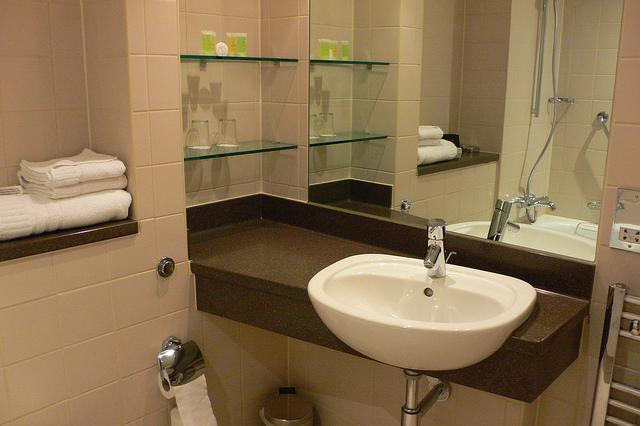Is this a fairly modern bathroom?
Concise answer only. Yes. What color are the towels in this picture?
Answer briefly. White. What room is this?
Be succinct. Bathroom. 